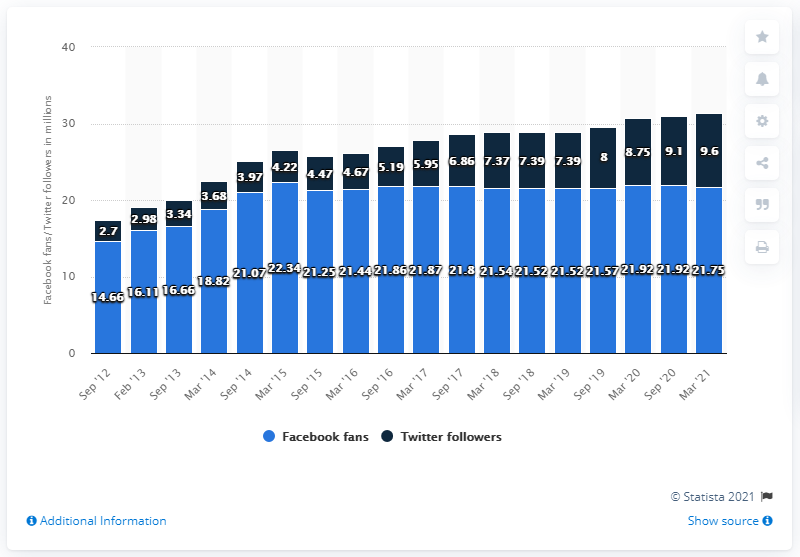Specify some key components in this picture. In March 2021, the Los Angeles Lakers basketball team had 21.75 Facebook followers. 